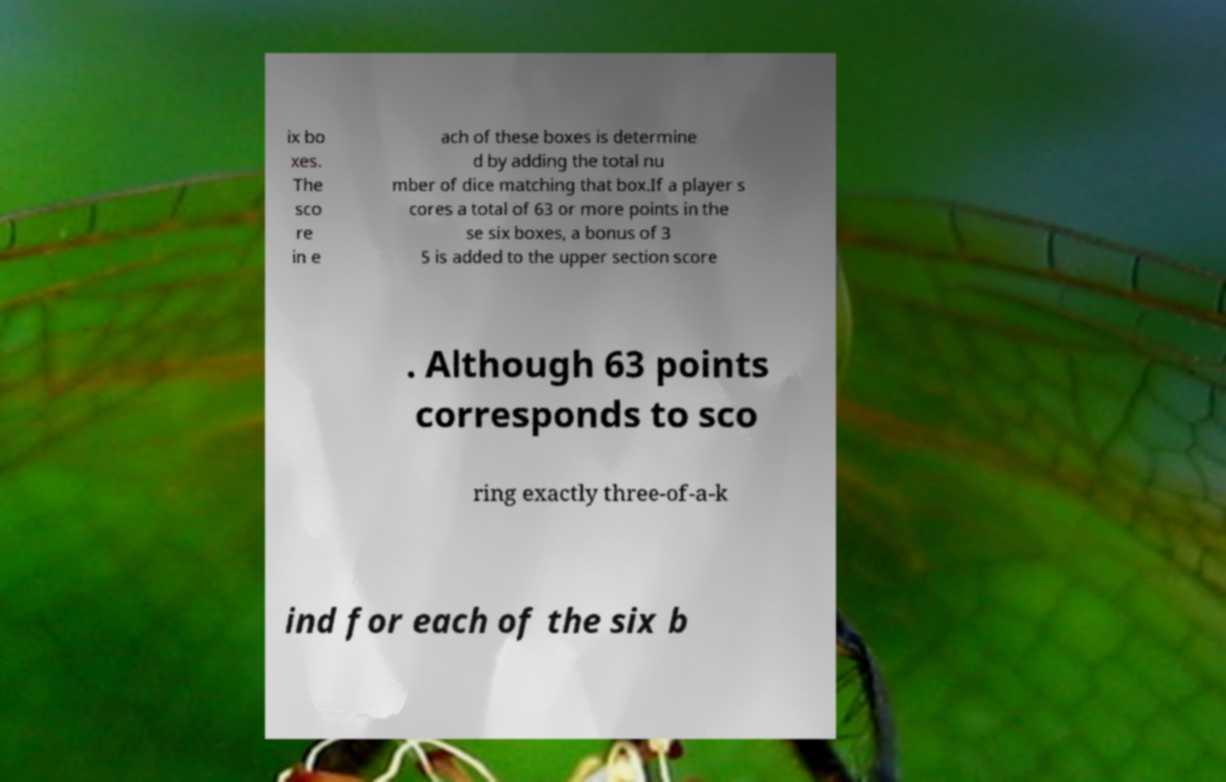Could you extract and type out the text from this image? ix bo xes. The sco re in e ach of these boxes is determine d by adding the total nu mber of dice matching that box.If a player s cores a total of 63 or more points in the se six boxes, a bonus of 3 5 is added to the upper section score . Although 63 points corresponds to sco ring exactly three-of-a-k ind for each of the six b 